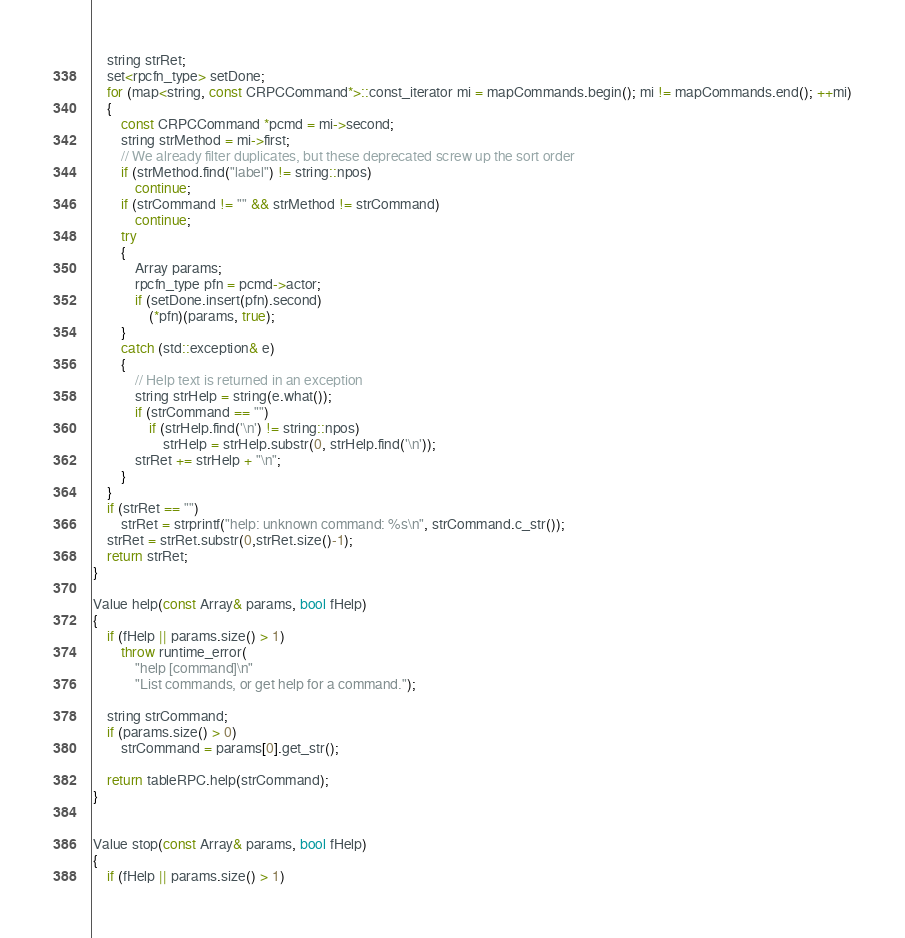Convert code to text. <code><loc_0><loc_0><loc_500><loc_500><_C++_>    string strRet;
    set<rpcfn_type> setDone;
    for (map<string, const CRPCCommand*>::const_iterator mi = mapCommands.begin(); mi != mapCommands.end(); ++mi)
    {
        const CRPCCommand *pcmd = mi->second;
        string strMethod = mi->first;
        // We already filter duplicates, but these deprecated screw up the sort order
        if (strMethod.find("label") != string::npos)
            continue;
        if (strCommand != "" && strMethod != strCommand)
            continue;
        try
        {
            Array params;
            rpcfn_type pfn = pcmd->actor;
            if (setDone.insert(pfn).second)
                (*pfn)(params, true);
        }
        catch (std::exception& e)
        {
            // Help text is returned in an exception
            string strHelp = string(e.what());
            if (strCommand == "")
                if (strHelp.find('\n') != string::npos)
                    strHelp = strHelp.substr(0, strHelp.find('\n'));
            strRet += strHelp + "\n";
        }
    }
    if (strRet == "")
        strRet = strprintf("help: unknown command: %s\n", strCommand.c_str());
    strRet = strRet.substr(0,strRet.size()-1);
    return strRet;
}

Value help(const Array& params, bool fHelp)
{
    if (fHelp || params.size() > 1)
        throw runtime_error(
            "help [command]\n"
            "List commands, or get help for a command.");

    string strCommand;
    if (params.size() > 0)
        strCommand = params[0].get_str();

    return tableRPC.help(strCommand);
}


Value stop(const Array& params, bool fHelp)
{
    if (fHelp || params.size() > 1)</code> 